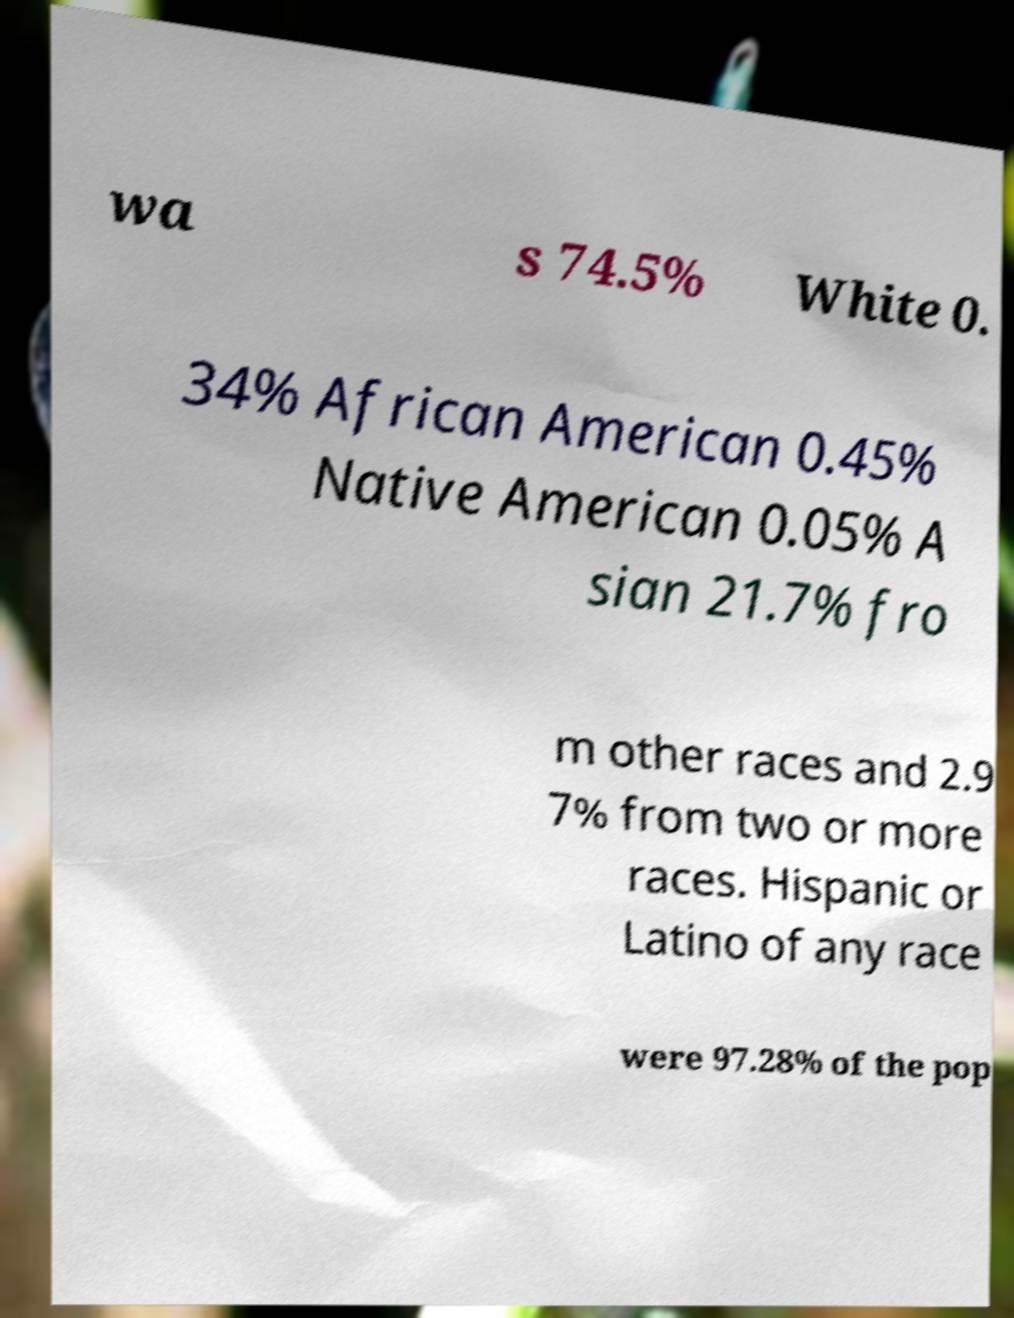Could you assist in decoding the text presented in this image and type it out clearly? wa s 74.5% White 0. 34% African American 0.45% Native American 0.05% A sian 21.7% fro m other races and 2.9 7% from two or more races. Hispanic or Latino of any race were 97.28% of the pop 